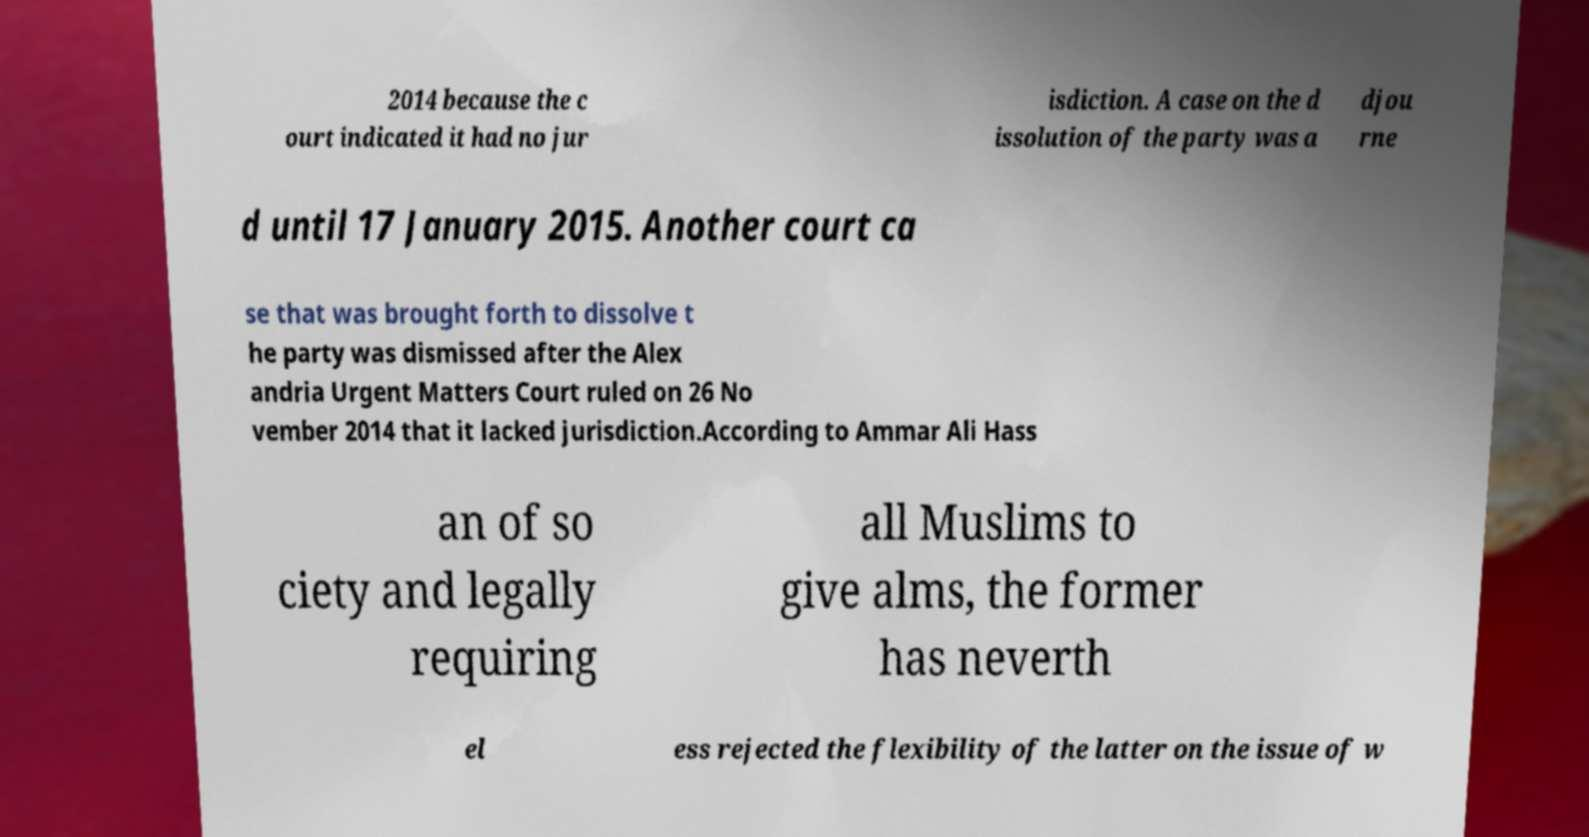Please read and relay the text visible in this image. What does it say? 2014 because the c ourt indicated it had no jur isdiction. A case on the d issolution of the party was a djou rne d until 17 January 2015. Another court ca se that was brought forth to dissolve t he party was dismissed after the Alex andria Urgent Matters Court ruled on 26 No vember 2014 that it lacked jurisdiction.According to Ammar Ali Hass an of so ciety and legally requiring all Muslims to give alms, the former has neverth el ess rejected the flexibility of the latter on the issue of w 